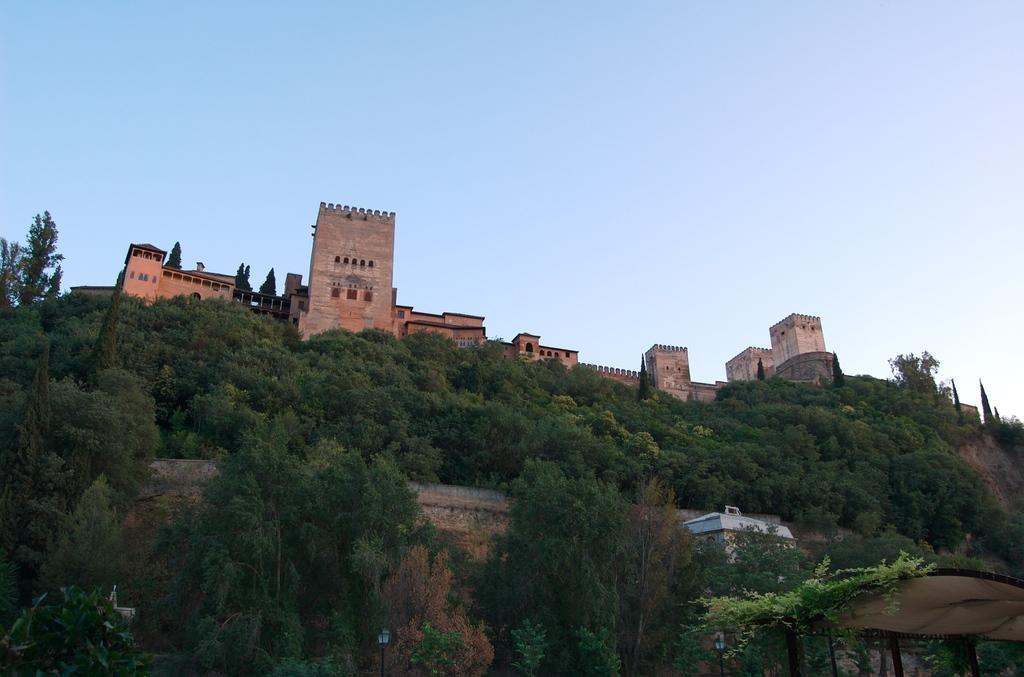What type of structure is the main subject of the image? There is a fort in the image. What can be seen in the foreground of the image? There are many trees in the image. What is visible in the background of the image? The sky and other buildings are visible in the background of the image. What type of bun is being cooked in the image? There is no bun or cooking activity present in the image; it features a fort, trees, and other buildings. What year is depicted in the image? The image does not depict a specific year; it is a photograph or illustration of a fort, trees, and other buildings. 